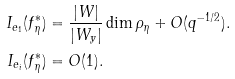Convert formula to latex. <formula><loc_0><loc_0><loc_500><loc_500>I _ { e _ { 1 } } ( f _ { \eta } ^ { * } ) & = \frac { | W | } { | W _ { y } | } \dim \rho _ { \eta } + O ( q ^ { - 1 / 2 } ) . \\ I _ { e _ { i } } ( f _ { \eta } ^ { * } ) & = O ( 1 ) .</formula> 